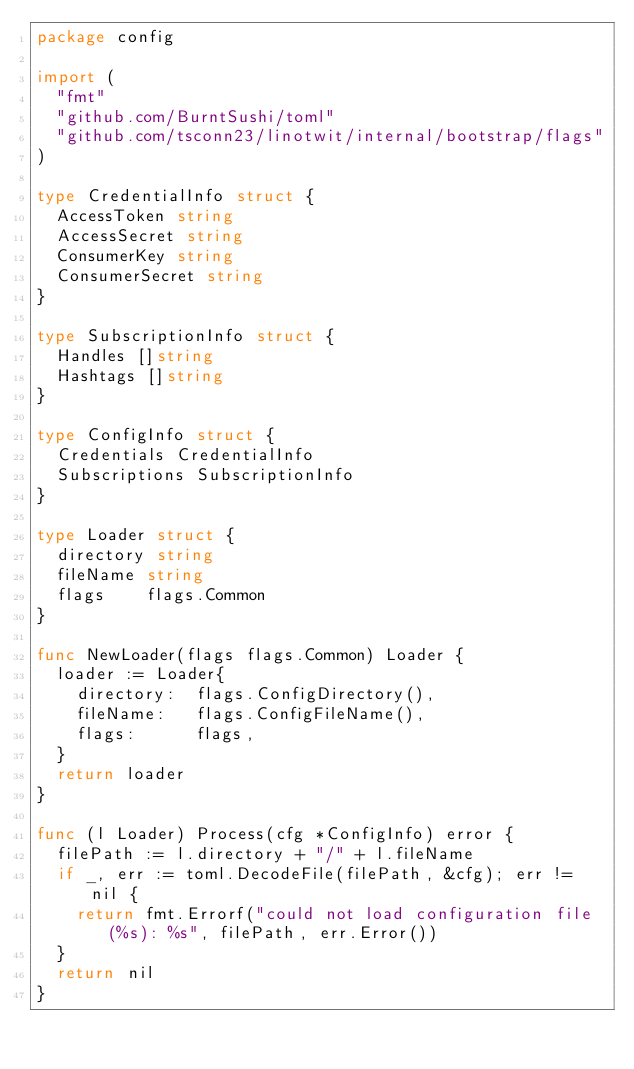Convert code to text. <code><loc_0><loc_0><loc_500><loc_500><_Go_>package config

import (
	"fmt"
	"github.com/BurntSushi/toml"
	"github.com/tsconn23/linotwit/internal/bootstrap/flags"
)

type CredentialInfo struct {
	AccessToken string
	AccessSecret string
	ConsumerKey string
	ConsumerSecret string
}

type SubscriptionInfo struct {
	Handles []string
	Hashtags []string
}

type ConfigInfo struct {
	Credentials CredentialInfo
	Subscriptions SubscriptionInfo
}

type Loader struct {
	directory string
	fileName string
	flags    flags.Common
}

func NewLoader(flags flags.Common) Loader {
	loader := Loader{
		directory:  flags.ConfigDirectory(),
		fileName:   flags.ConfigFileName(),
		flags:      flags,
	}
	return loader
}

func (l Loader) Process(cfg *ConfigInfo) error {
	filePath := l.directory + "/" + l.fileName
	if _, err := toml.DecodeFile(filePath, &cfg); err != nil {
		return fmt.Errorf("could not load configuration file (%s): %s", filePath, err.Error())
	}
	return nil
}</code> 